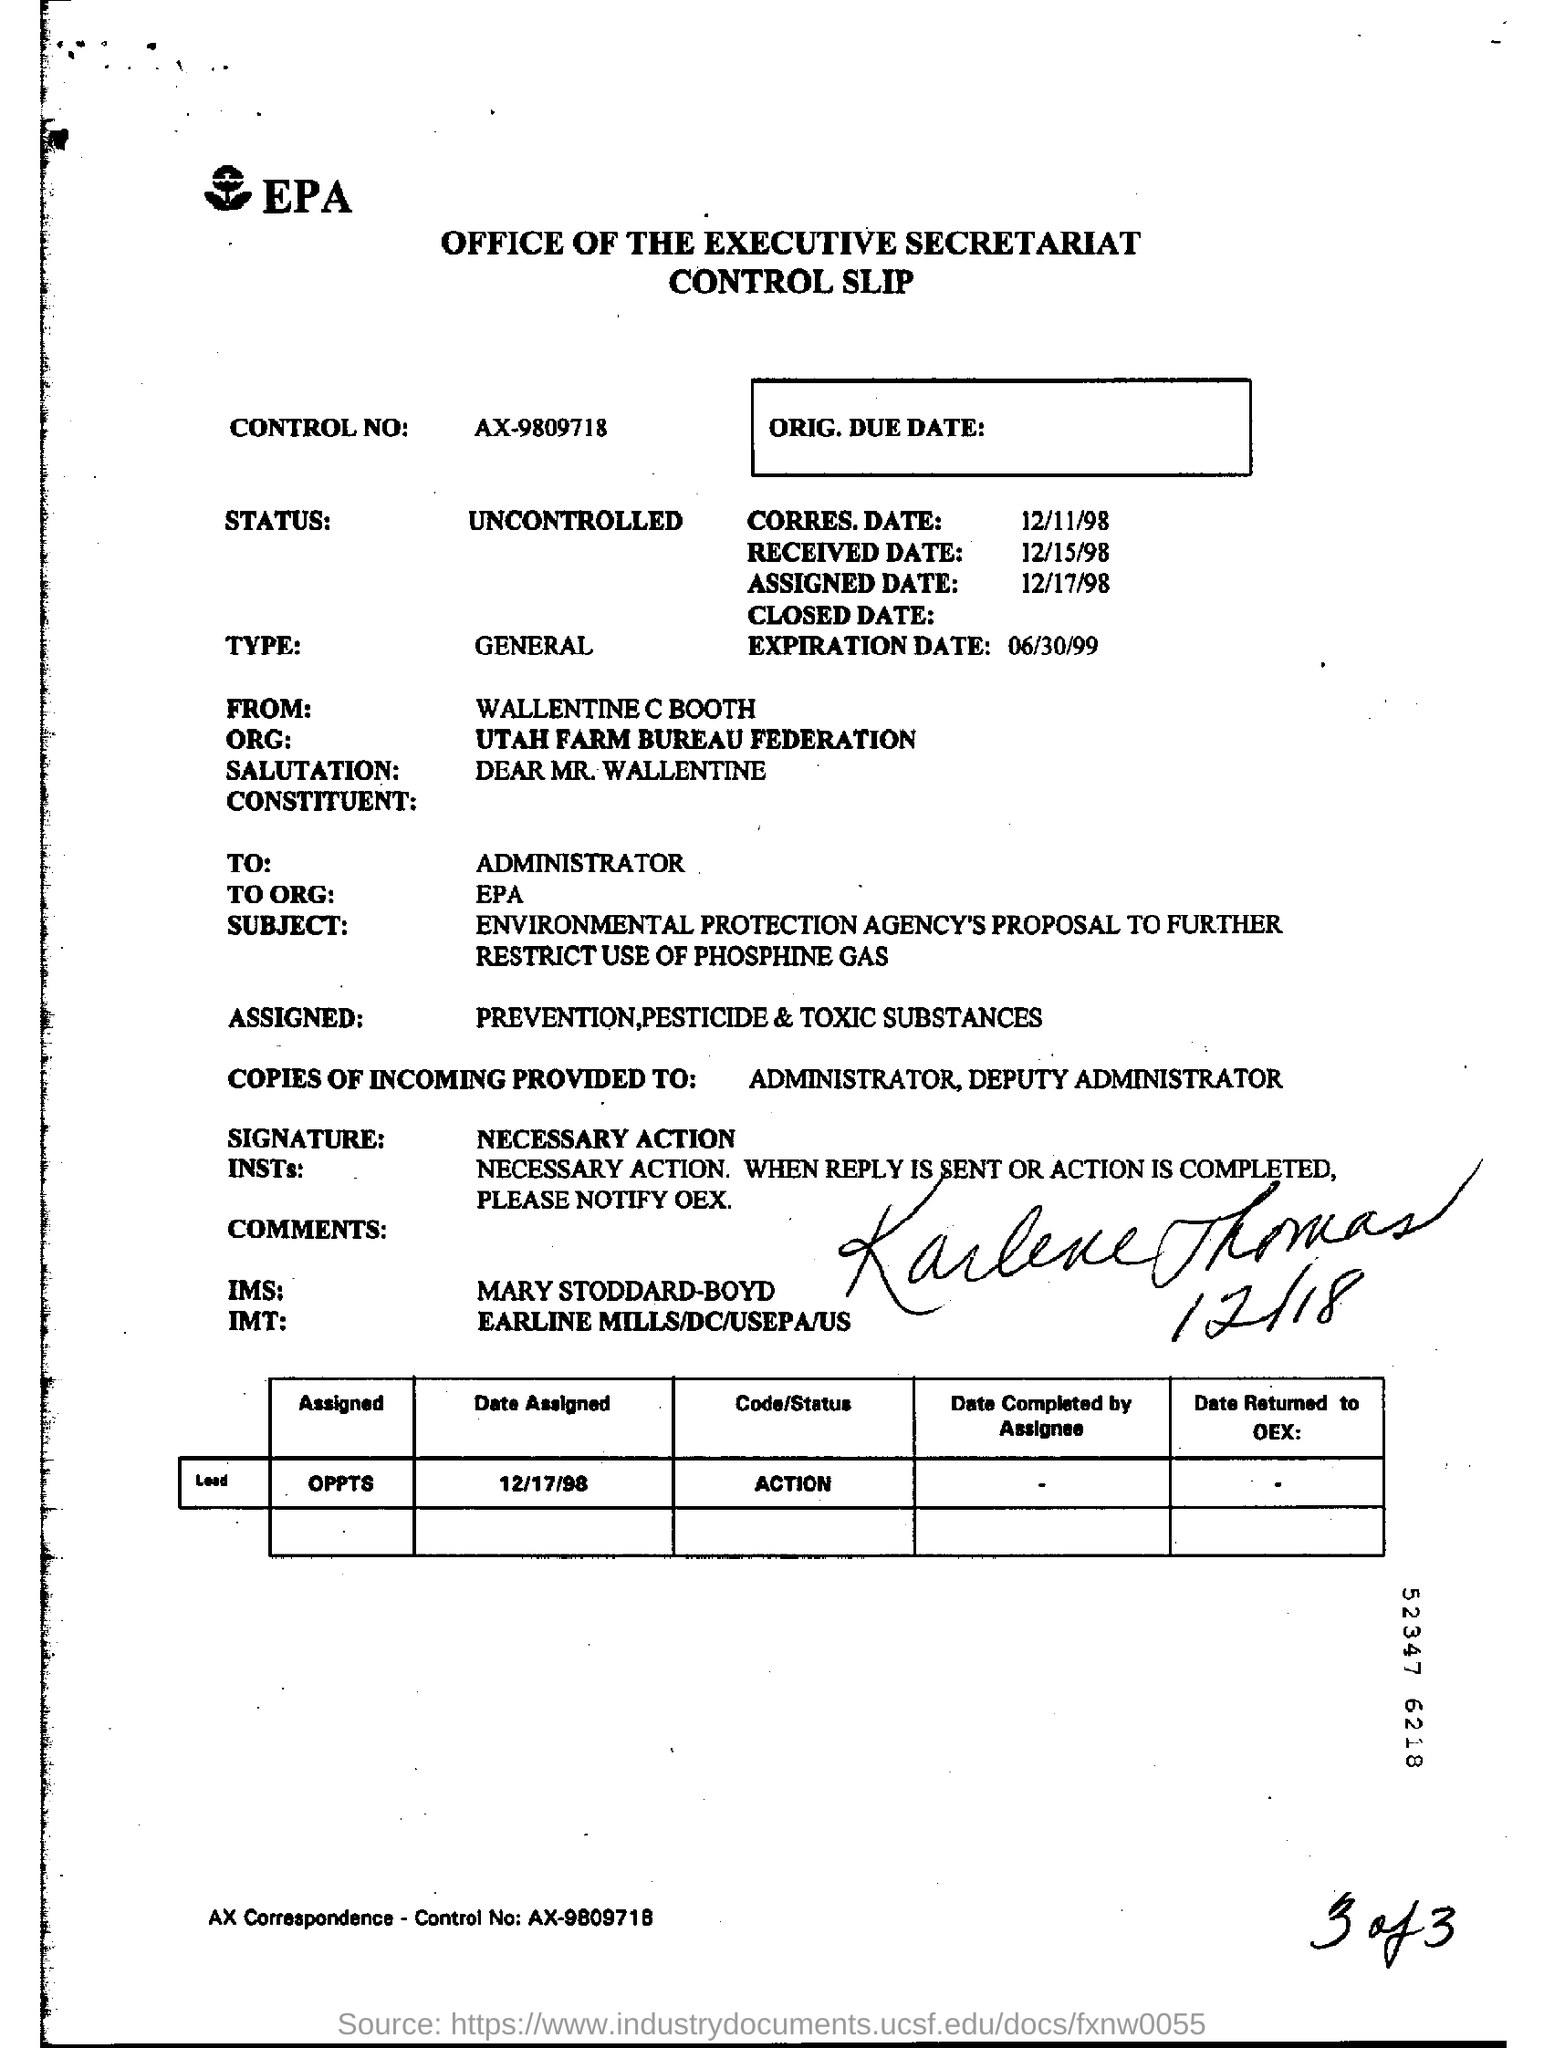Identify some key points in this picture. The slip is from WALLENTINE C BOOTH. The expiration date is June 30, 1999. What is the control number AX-9809718? 